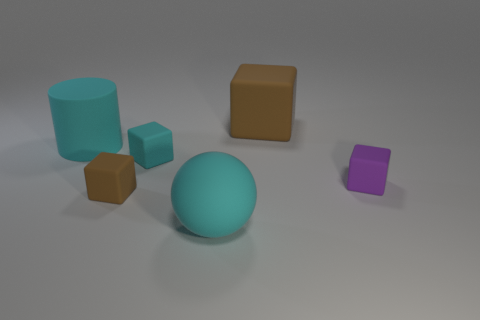Subtract all small brown matte cubes. How many cubes are left? 3 Subtract 2 blocks. How many blocks are left? 2 Add 3 small rubber things. How many objects exist? 9 Subtract all cyan blocks. How many blocks are left? 3 Subtract all cyan cubes. Subtract all purple cylinders. How many cubes are left? 3 Subtract all blocks. How many objects are left? 2 Subtract all big blue cylinders. Subtract all large blocks. How many objects are left? 5 Add 6 tiny cyan matte objects. How many tiny cyan matte objects are left? 7 Add 4 cyan rubber spheres. How many cyan rubber spheres exist? 5 Subtract 0 red blocks. How many objects are left? 6 